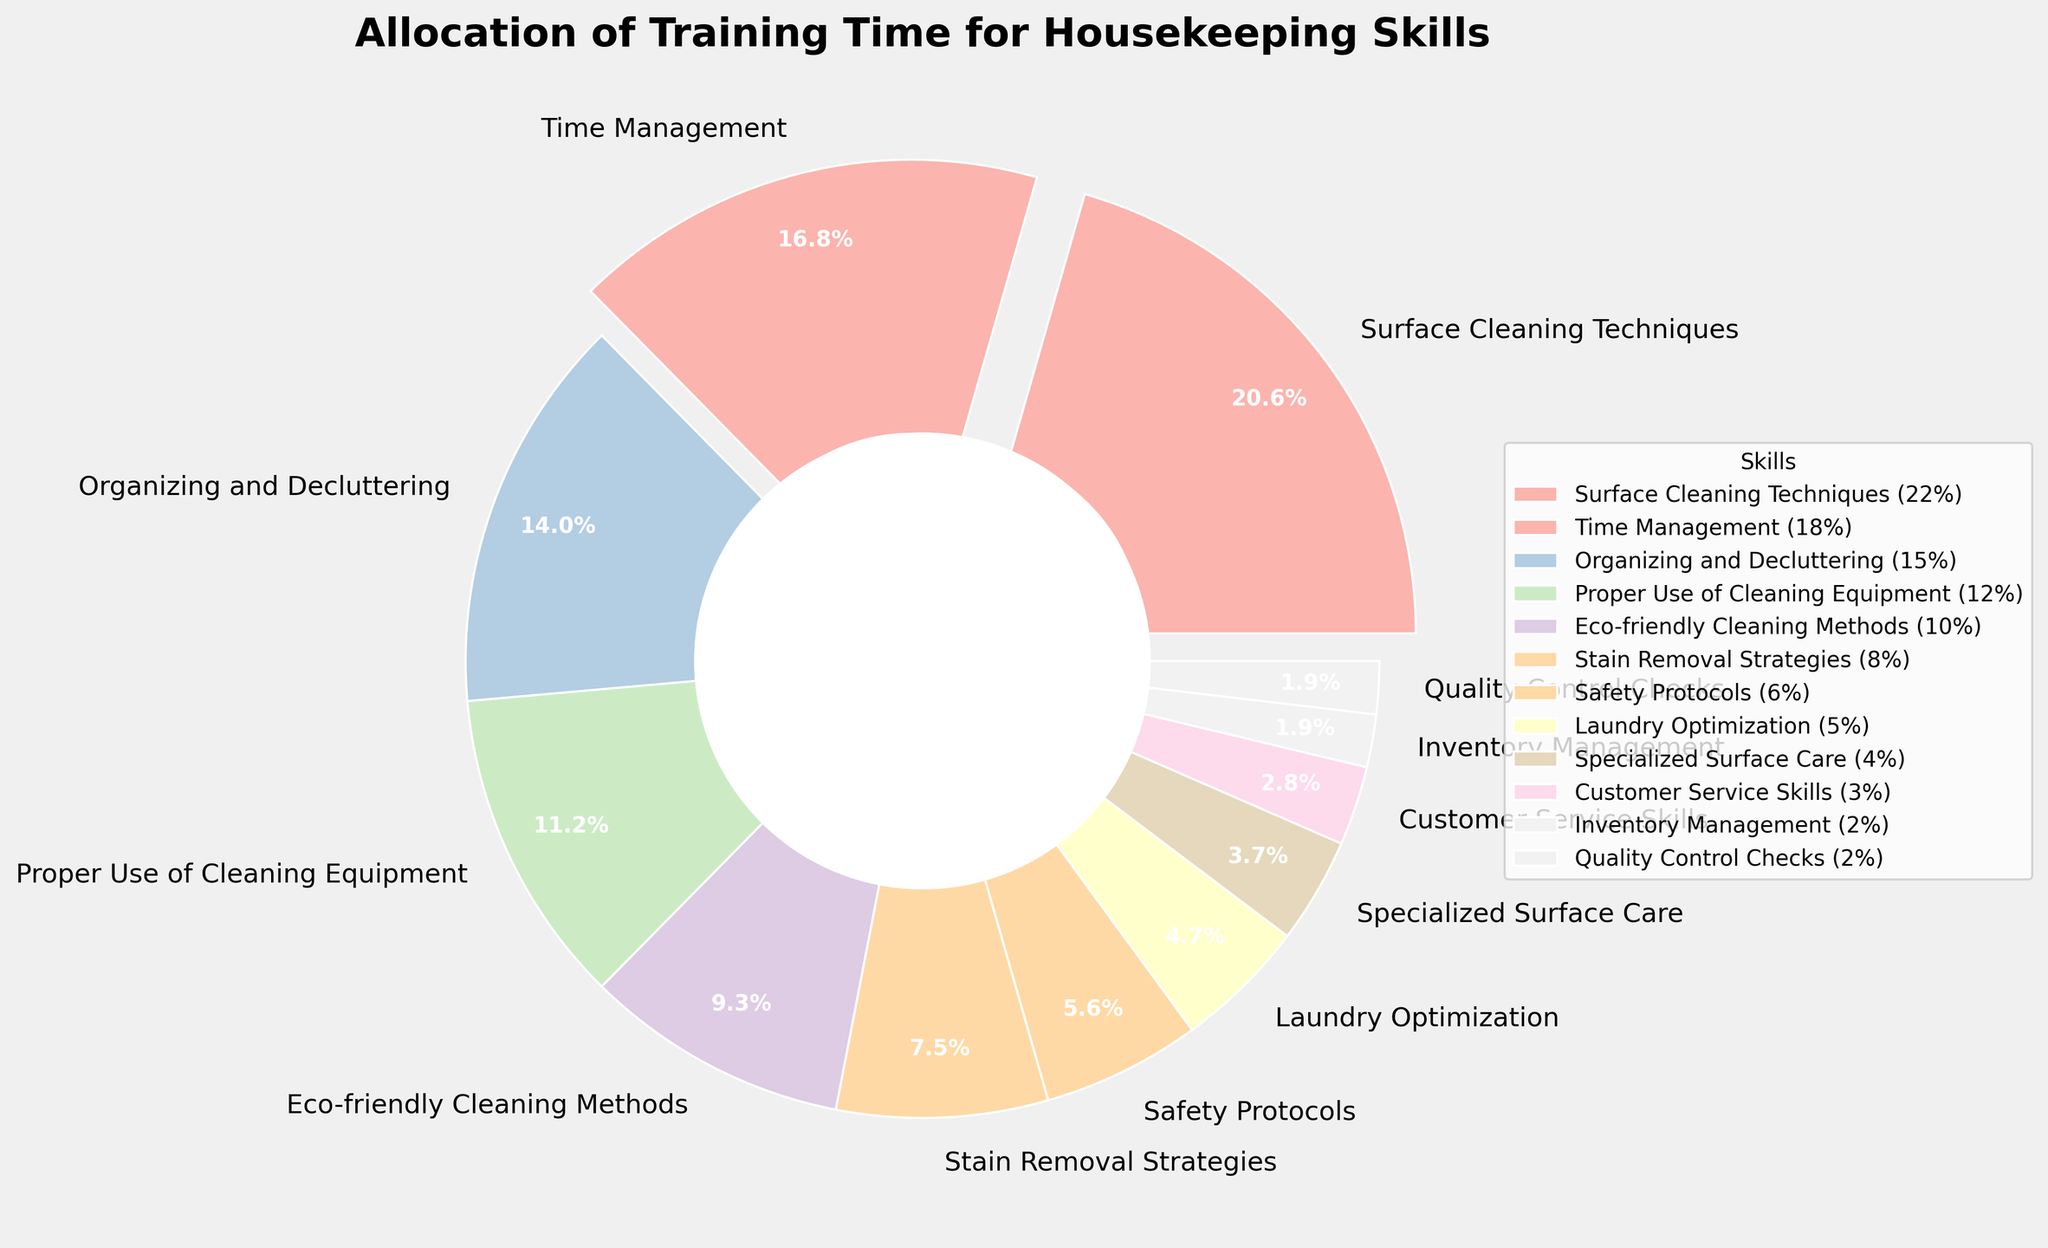What skill takes up the largest percentage of training time? The largest slice of the pie chart corresponds to "Surface Cleaning Techniques". By visually inspecting, this segment occupies 22% of the pie chart.
Answer: Surface Cleaning Techniques Which two skills combined cover more than one-third of the total training time? Adding the percentages of the largest two segments, "Surface Cleaning Techniques" (22%) and "Time Management" (18%), gives a total of 40%. Since 40% is greater than one-third (33.3%), these two skills together cover more than one-third of the total training time.
Answer: Surface Cleaning Techniques and Time Management What proportion of the training time is allocated to skills related to equipment usage and eco-friendliness? Summing the percentages of "Proper Use of Cleaning Equipment" (12%) and "Eco-friendly Cleaning Methods" (10%) results in a total of 22%.
Answer: 22% Which skill has the smallest allocation of training time, and what percentage does it represent? The smallest segment in the pie chart corresponds to "Inventory Management" and "Quality Control Checks," both of which have equal and smallest percentages of 2%.
Answer: Inventory Management and Quality Control Checks Is the proportion of training time for "Stain Removal Strategies" greater than, less than, or equal to the combined time for "Customer Service Skills" and "Inventory Management"? "Stain Removal Strategies" occupies 8% of the training time. The combined time for "Customer Service Skills" (3%) and "Inventory Management" (2%) equals 5%. Therefore, 8% is greater than 5%.
Answer: Greater than How much more is the percentage allocated to "Surface Cleaning Techniques" than to "Organizing and Decluttering"? "Surface Cleaning Techniques" is allocated 22%, while "Organizing and Decluttering" is allocated 15%. The difference is 22% - 15%, which equals 7%.
Answer: 7% What's the total percentage allocated to "Safety Protocols" and "Laundry Optimization"? Adding the percentages of "Safety Protocols" (6%) and "Laundry Optimization" (5%) results in a total of 11%.
Answer: 11% Compare the allocation of training time for "Specialized Surface Care" and "Customer Service Skills". Which one is larger and by how much? "Specialized Surface Care" is allocated 4%, while "Customer Service Skills" is allocated 3%. The difference is 4% - 3%, which equals 1%. Therefore, "Specialized Surface Care" is larger by 1%.
Answer: Specialized Surface Care by 1% 